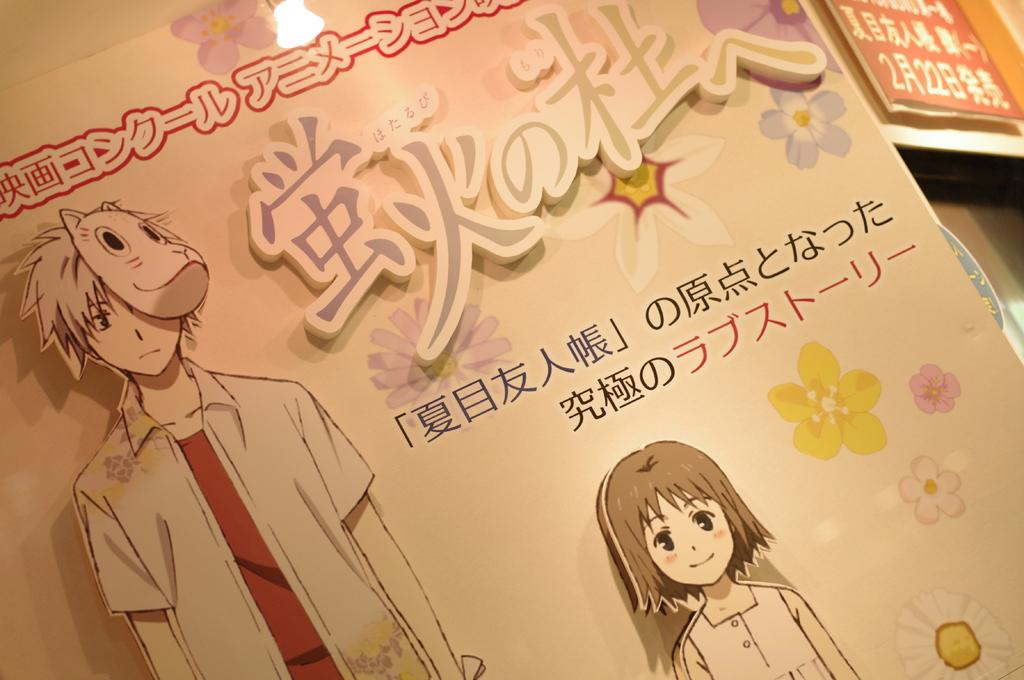What type of publication is visible in the image? There is a magazine in the image. What kind of content can be found in the magazine? There is a cartoon and flower paintings in the magazine. What language is used in the magazine? There are Chinese language words in the magazine. How does the moon affect the cartoon in the magazine? The moon does not affect the cartoon in the magazine, as there is no moon present in the image. 